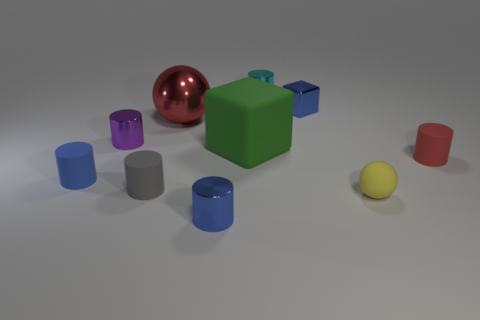There is a red thing on the right side of the blue metallic object that is on the left side of the small blue shiny object that is behind the small yellow thing; what is its material?
Give a very brief answer. Rubber. The green thing that is the same size as the red sphere is what shape?
Your response must be concise. Cube. Are there any tiny cylinders that have the same color as the large shiny sphere?
Offer a terse response. Yes. What is the size of the blue block?
Offer a terse response. Small. Are the small gray cylinder and the tiny red cylinder made of the same material?
Your answer should be compact. Yes. How many small blue cylinders are right of the small blue thing that is to the right of the blue shiny thing in front of the tiny purple metal cylinder?
Your response must be concise. 0. What is the shape of the blue shiny object that is behind the small gray matte cylinder?
Give a very brief answer. Cube. What number of other things are the same material as the small cube?
Offer a terse response. 4. Is the number of tiny blue cubes in front of the green cube less than the number of tiny metal cylinders behind the large metallic sphere?
Offer a very short reply. Yes. The metallic thing that is the same shape as the large green matte thing is what color?
Provide a succinct answer. Blue. 